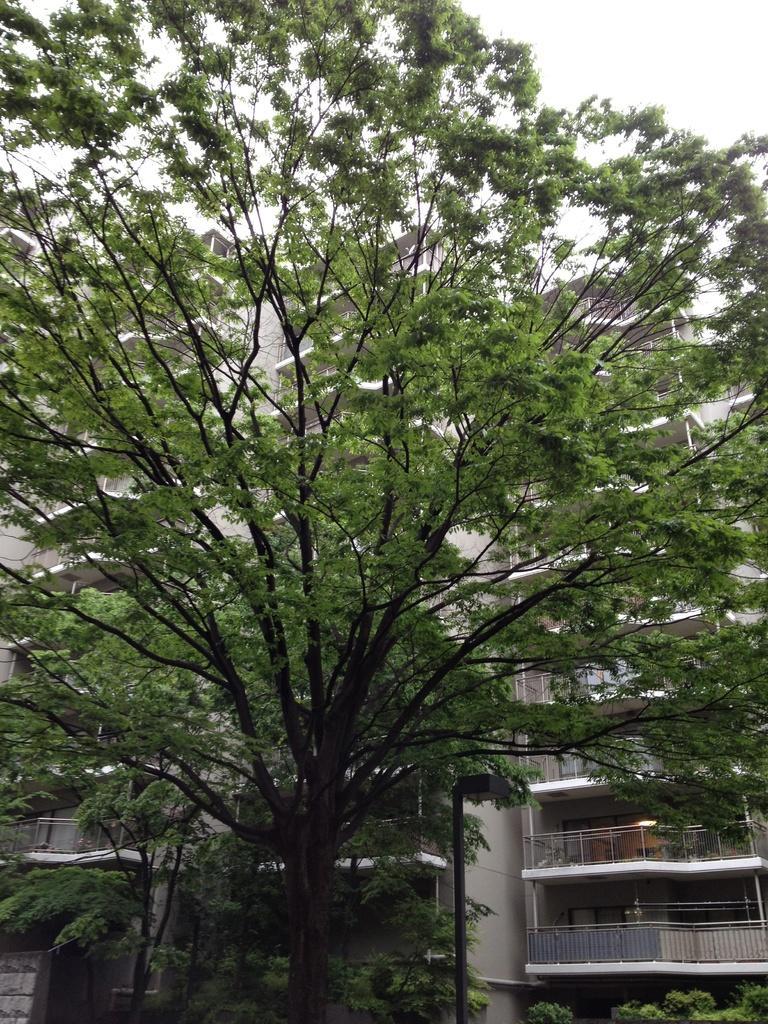In one or two sentences, can you explain what this image depicts? In this picture we can see trees and behind the trees there are buildings and a sky. 